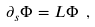Convert formula to latex. <formula><loc_0><loc_0><loc_500><loc_500>\partial _ { s } \Phi = L \Phi \ ,</formula> 